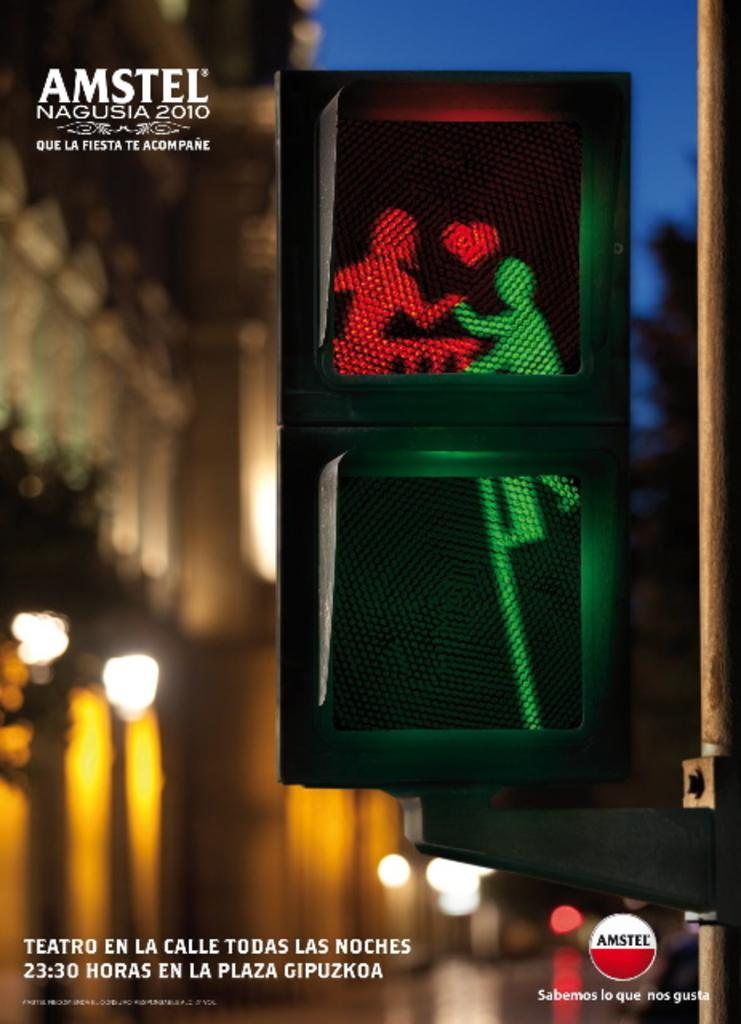<image>
Offer a succinct explanation of the picture presented. A sign has Amstel in the left and lower right corner. 